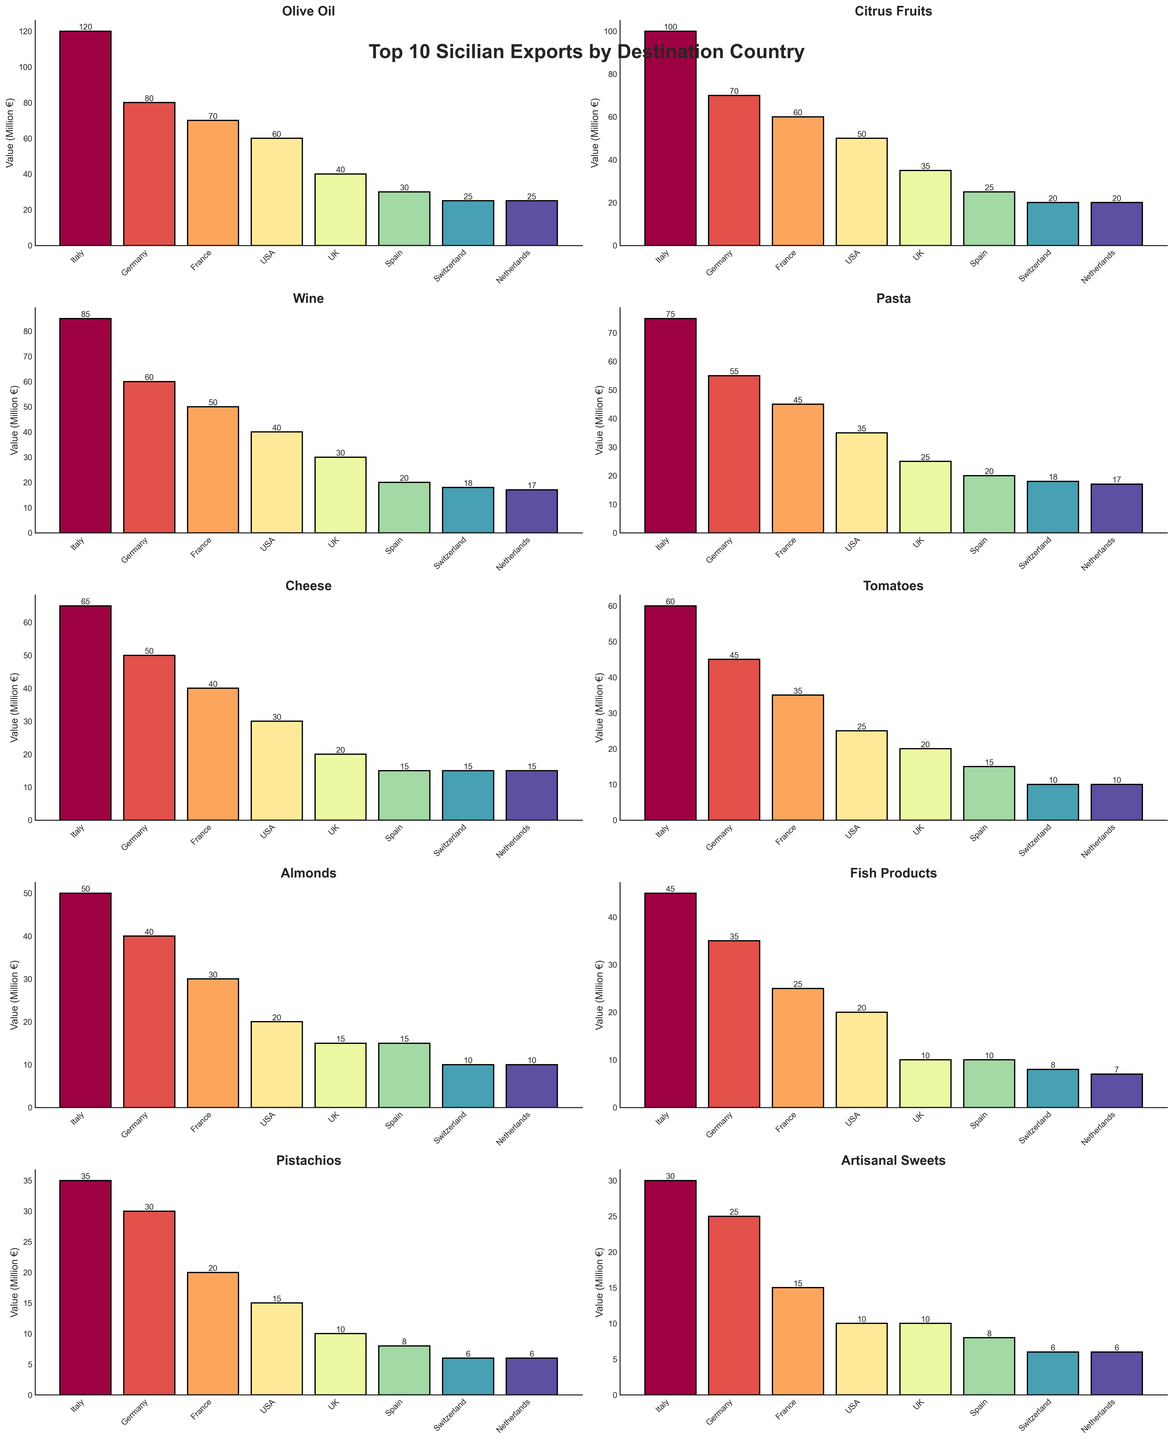Which export has the highest value in Italy? Look at the bar heights representing the values for Italy in each subplot. Olive Oil has the highest bar, meaning it has the highest value in Italy.
Answer: Olive Oil Which country receives the least Artisanal Sweets in value? In the Artisanal Sweets subplot, check the bars to see which one is the shortest. Switzerland and Netherlands both have the shortest bars for Artisanal Sweets.
Answer: Switzerland, Netherlands What is the total value of Citrus Fruits exported to all countries? Add up the values for Citrus Fruits from each country: 100 + 70 + 60 + 50 + 35 + 25 + 20 + 20 = 380 million €
Answer: 380 million € Which export has the highest combined value in Germany and France? Add the values for Germany and France for each export: Olive Oil (80 + 70), Citrus Fruits (70 + 60), Wine (60 + 50), etc. Olive Oil has the highest combined value of 150 million €.
Answer: Olive Oil Which country receives more Almonds: Switzerland or Netherlands? Compare the bar heights for Almonds between Switzerland and Netherlands. Both bars are equal in height at 10 million €.
Answer: Equal How much more Olive Oil does Italy import compared to the USA? Subtract the value for the USA from the value for Italy for Olive Oil: 120 - 60 = 60 million €
Answer: 60 million € Which export has a higher value in the Netherlands, Wine or Pistachios? Compare the bars for the Netherlands in the Wine and Pistachios subplots. The bar for Wine (17) is higher than the bar for Pistachios (6).
Answer: Wine What is the second highest export value to the UK? In each subplot, identify the values for the UK, then find the second highest one. Olive Oil (40), Citrus Fruits (35), Wine (30), etc. The second highest is Wine with a value of 30 million €.
Answer: Wine What is the total value of exports to Switzerland for Cheese and Fish Products combined? Add the values for Switzerland for Cheese and Fish Products: 15 + 10 = 25 million €.
Answer: 25 million € Which export has a higher average value per country: Pasta or Tomatoes? Calculate the average value per country for each: Pasta (75 + 55 + 45 + 35 + 25 + 20 + 18 + 17) / 8 = 36.25, Tomatoes (60 + 45 + 35 + 25 + 20 + 15 + 10 + 10) / 8 = 27.5. Pasta has the higher average.
Answer: Pasta 